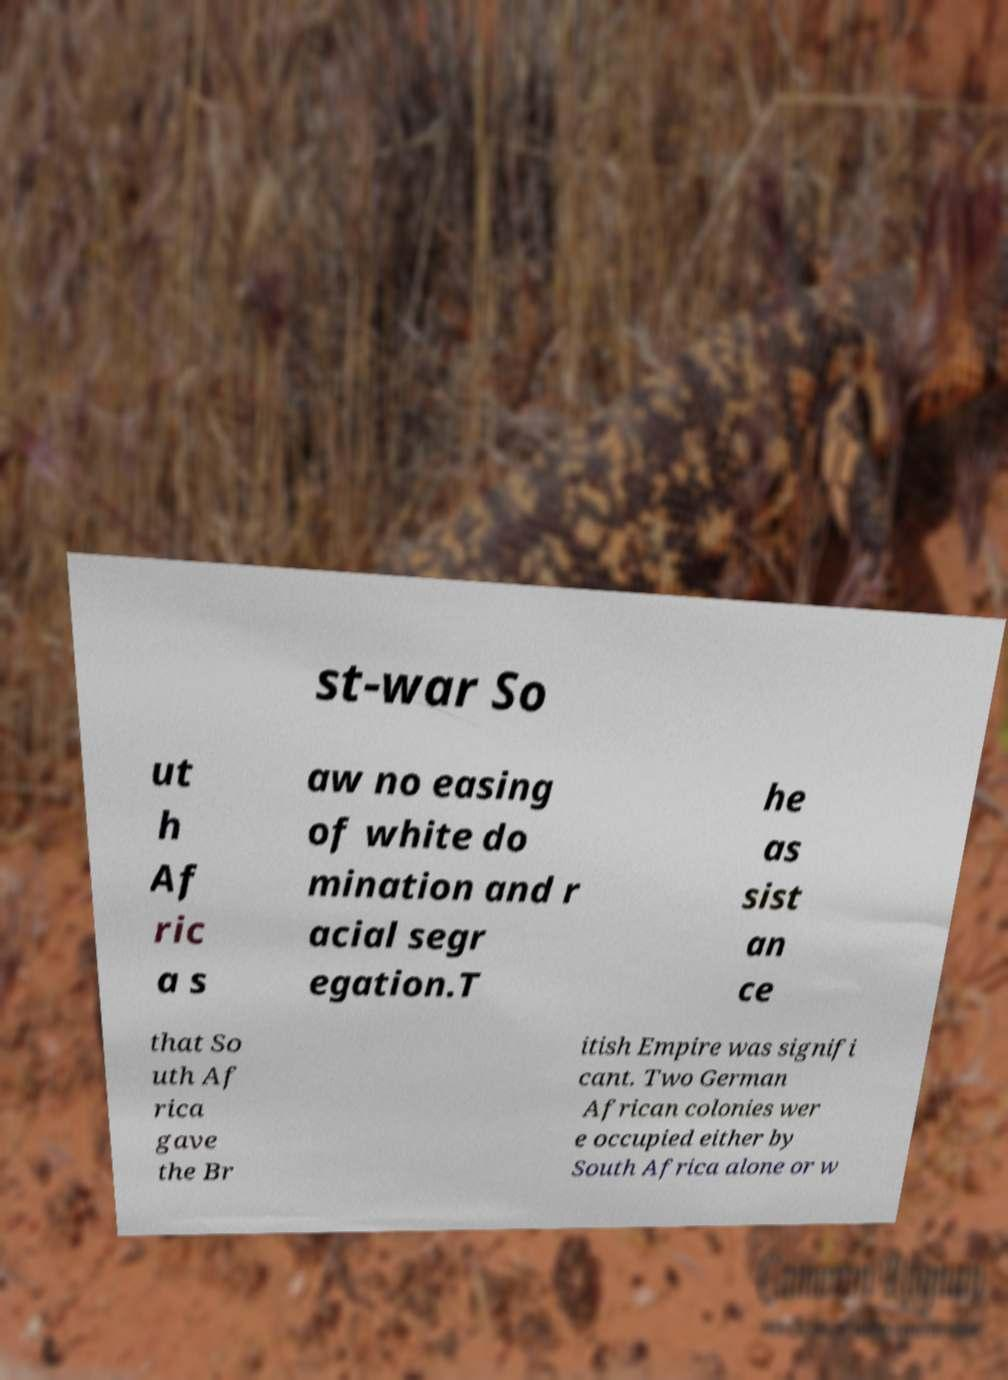Could you assist in decoding the text presented in this image and type it out clearly? st-war So ut h Af ric a s aw no easing of white do mination and r acial segr egation.T he as sist an ce that So uth Af rica gave the Br itish Empire was signifi cant. Two German African colonies wer e occupied either by South Africa alone or w 